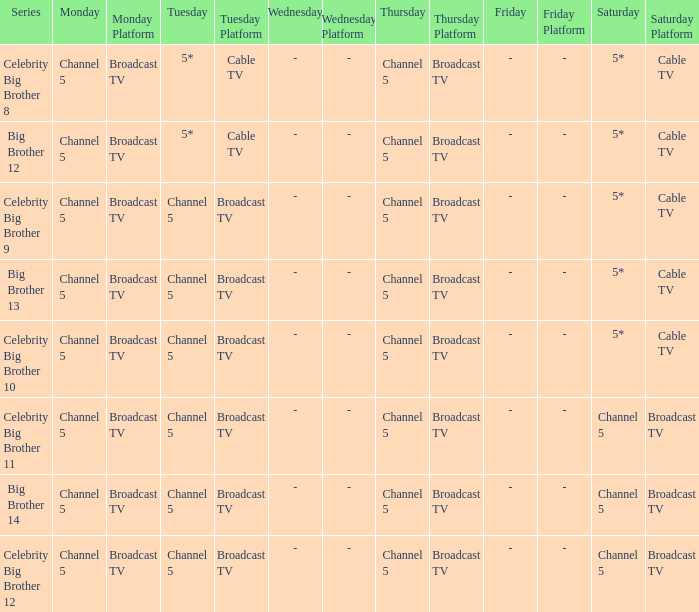Which series airs Saturday on Channel 5? Celebrity Big Brother 11, Big Brother 14, Celebrity Big Brother 12. 